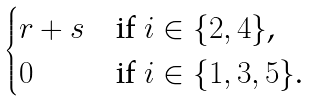<formula> <loc_0><loc_0><loc_500><loc_500>\begin{cases} r + s & \text {if $i\in\{2,4\}$,} \\ 0 & \text {if $i\in\{1,3,5\}$.} \end{cases}</formula> 